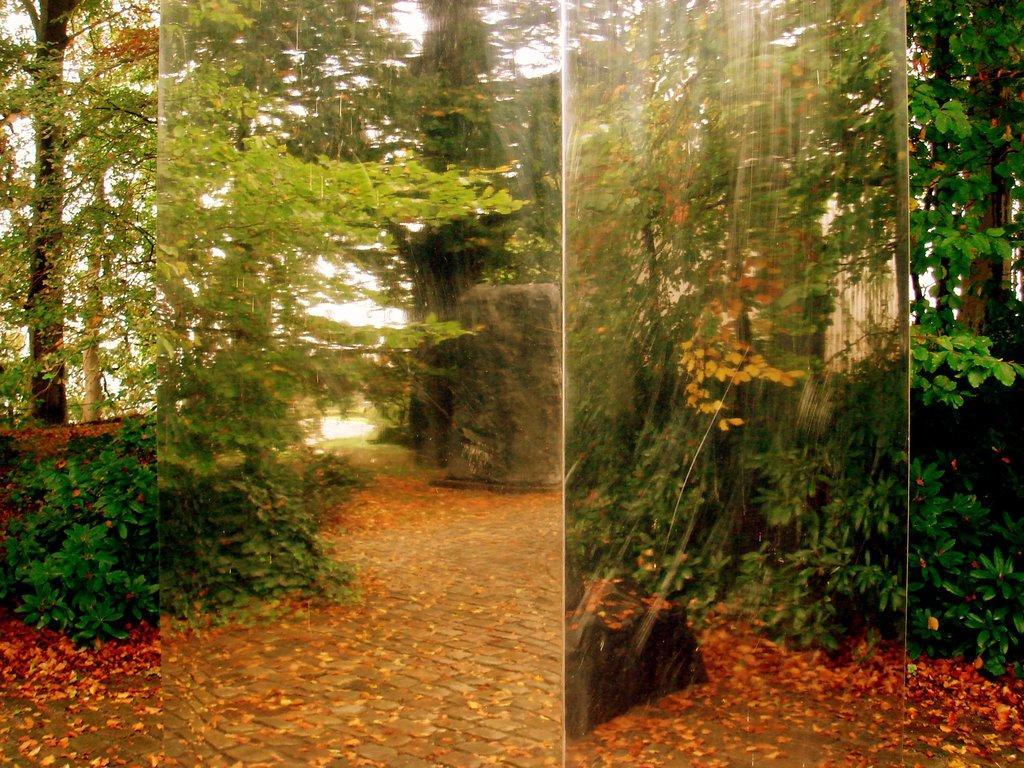Please provide a concise description of this image. In this image we can two pictures in which we can see see dry leaves on the ground, here we can see the plants, trees and the stones in the background. This part of the image is blurred. 